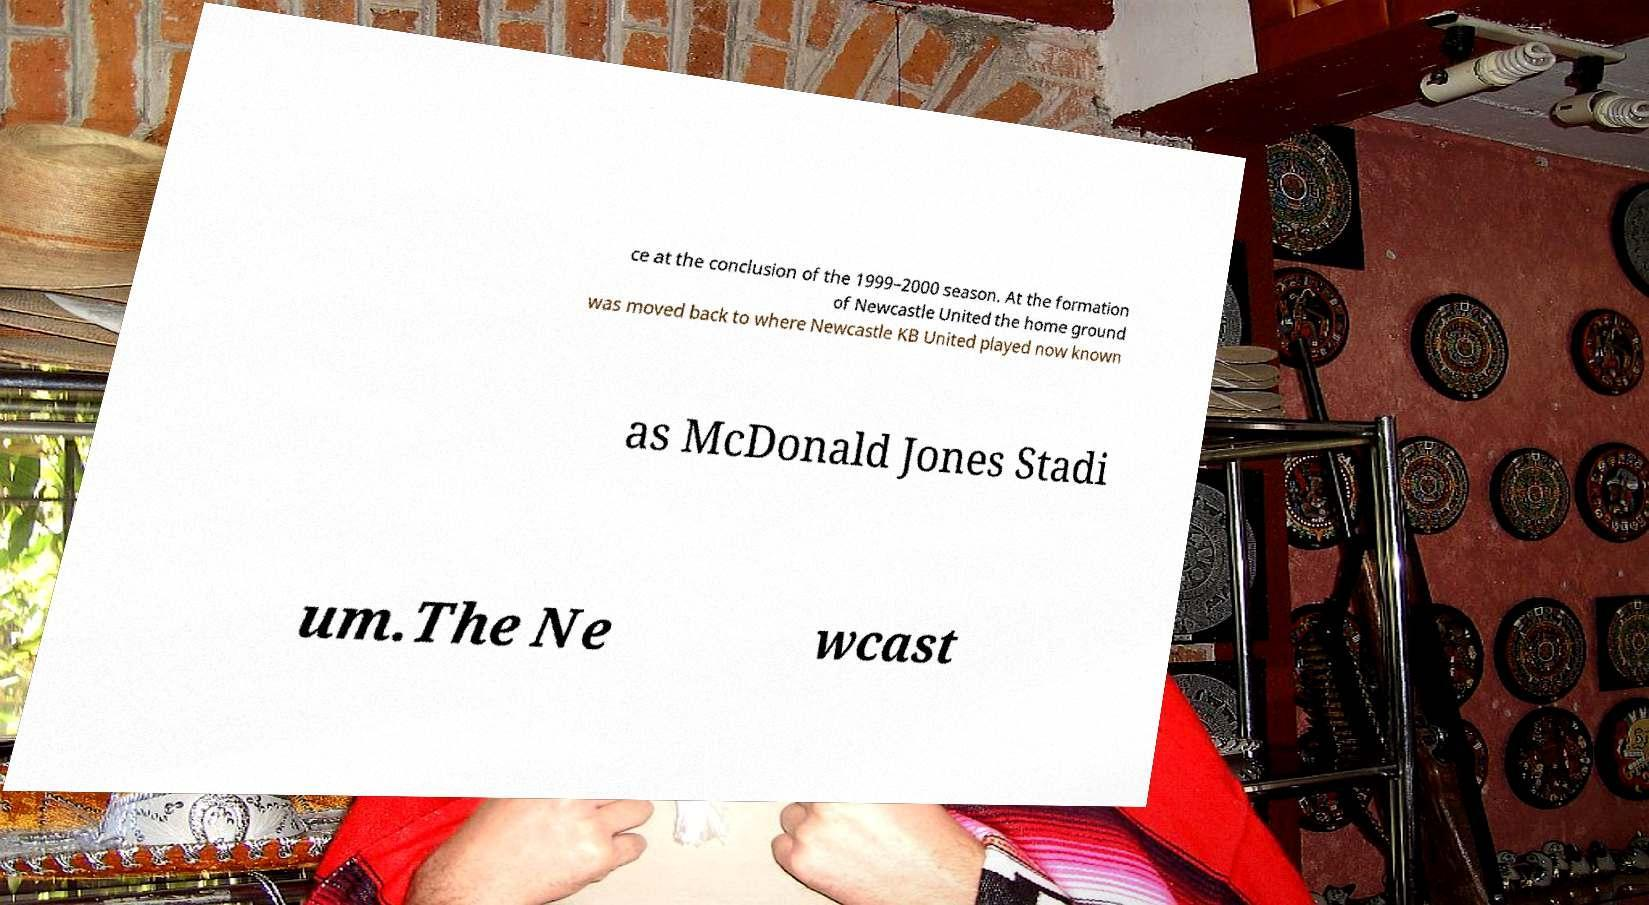There's text embedded in this image that I need extracted. Can you transcribe it verbatim? ce at the conclusion of the 1999–2000 season. At the formation of Newcastle United the home ground was moved back to where Newcastle KB United played now known as McDonald Jones Stadi um.The Ne wcast 